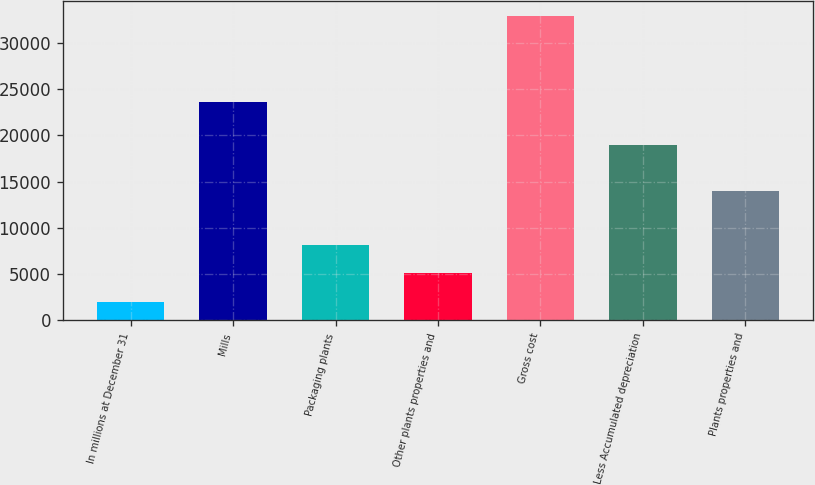<chart> <loc_0><loc_0><loc_500><loc_500><bar_chart><fcel>In millions at December 31<fcel>Mills<fcel>Packaging plants<fcel>Other plants properties and<fcel>Gross cost<fcel>Less Accumulated depreciation<fcel>Plants properties and<nl><fcel>2012<fcel>23625<fcel>8186.2<fcel>5099.1<fcel>32883<fcel>18934<fcel>13949<nl></chart> 